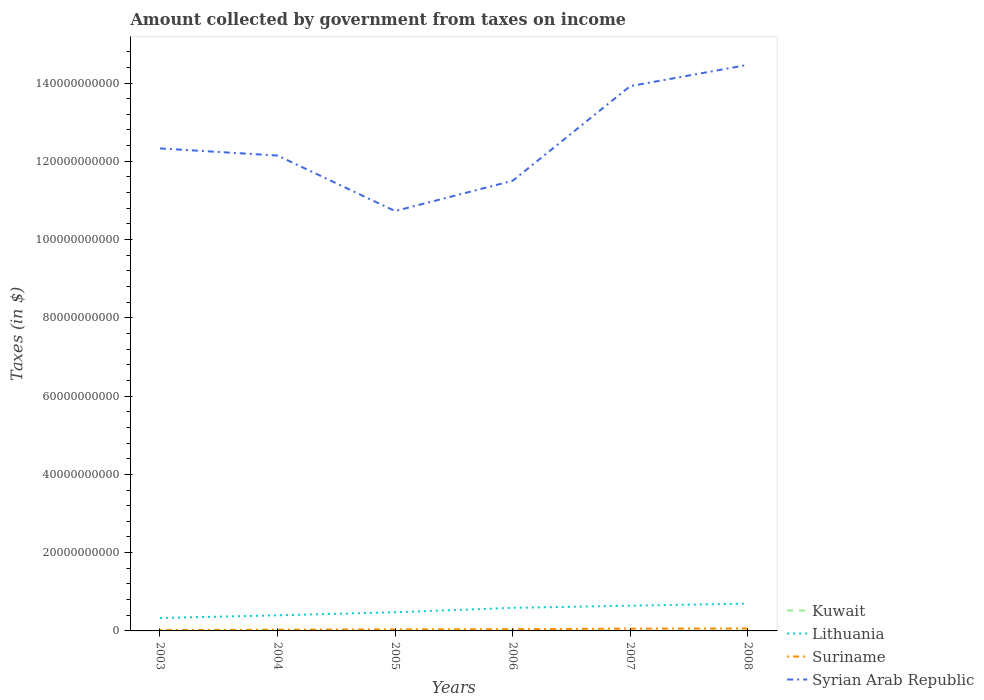Does the line corresponding to Lithuania intersect with the line corresponding to Syrian Arab Republic?
Your answer should be very brief. No. Across all years, what is the maximum amount collected by government from taxes on income in Syrian Arab Republic?
Your answer should be compact. 1.07e+11. In which year was the amount collected by government from taxes on income in Suriname maximum?
Provide a succinct answer. 2003. What is the total amount collected by government from taxes on income in Suriname in the graph?
Keep it short and to the point. -2.92e+08. What is the difference between the highest and the second highest amount collected by government from taxes on income in Lithuania?
Your answer should be compact. 3.69e+09. Is the amount collected by government from taxes on income in Suriname strictly greater than the amount collected by government from taxes on income in Kuwait over the years?
Provide a succinct answer. No. How many lines are there?
Offer a terse response. 4. How many years are there in the graph?
Ensure brevity in your answer.  6. What is the difference between two consecutive major ticks on the Y-axis?
Your answer should be very brief. 2.00e+1. Are the values on the major ticks of Y-axis written in scientific E-notation?
Your answer should be compact. No. Does the graph contain any zero values?
Offer a terse response. No. Where does the legend appear in the graph?
Your answer should be compact. Bottom right. What is the title of the graph?
Provide a short and direct response. Amount collected by government from taxes on income. What is the label or title of the X-axis?
Your answer should be very brief. Years. What is the label or title of the Y-axis?
Offer a terse response. Taxes (in $). What is the Taxes (in $) of Kuwait in 2003?
Keep it short and to the point. 3.00e+07. What is the Taxes (in $) in Lithuania in 2003?
Offer a terse response. 3.29e+09. What is the Taxes (in $) of Suriname in 2003?
Provide a short and direct response. 2.10e+08. What is the Taxes (in $) of Syrian Arab Republic in 2003?
Ensure brevity in your answer.  1.23e+11. What is the Taxes (in $) in Kuwait in 2004?
Your answer should be very brief. 5.30e+07. What is the Taxes (in $) in Lithuania in 2004?
Your answer should be compact. 3.99e+09. What is the Taxes (in $) of Suriname in 2004?
Give a very brief answer. 3.03e+08. What is the Taxes (in $) in Syrian Arab Republic in 2004?
Your answer should be compact. 1.21e+11. What is the Taxes (in $) in Kuwait in 2005?
Provide a short and direct response. 5.80e+07. What is the Taxes (in $) in Lithuania in 2005?
Offer a very short reply. 4.77e+09. What is the Taxes (in $) in Suriname in 2005?
Your answer should be very brief. 3.90e+08. What is the Taxes (in $) in Syrian Arab Republic in 2005?
Your answer should be very brief. 1.07e+11. What is the Taxes (in $) of Kuwait in 2006?
Make the answer very short. 8.20e+07. What is the Taxes (in $) in Lithuania in 2006?
Provide a succinct answer. 5.89e+09. What is the Taxes (in $) in Suriname in 2006?
Offer a terse response. 4.40e+08. What is the Taxes (in $) in Syrian Arab Republic in 2006?
Keep it short and to the point. 1.15e+11. What is the Taxes (in $) of Kuwait in 2007?
Offer a terse response. 1.09e+08. What is the Taxes (in $) of Lithuania in 2007?
Your answer should be very brief. 6.44e+09. What is the Taxes (in $) of Suriname in 2007?
Your response must be concise. 5.95e+08. What is the Taxes (in $) of Syrian Arab Republic in 2007?
Keep it short and to the point. 1.39e+11. What is the Taxes (in $) of Kuwait in 2008?
Your answer should be compact. 1.22e+08. What is the Taxes (in $) in Lithuania in 2008?
Offer a terse response. 6.99e+09. What is the Taxes (in $) in Suriname in 2008?
Make the answer very short. 6.34e+08. What is the Taxes (in $) in Syrian Arab Republic in 2008?
Your response must be concise. 1.45e+11. Across all years, what is the maximum Taxes (in $) in Kuwait?
Ensure brevity in your answer.  1.22e+08. Across all years, what is the maximum Taxes (in $) of Lithuania?
Offer a terse response. 6.99e+09. Across all years, what is the maximum Taxes (in $) in Suriname?
Give a very brief answer. 6.34e+08. Across all years, what is the maximum Taxes (in $) of Syrian Arab Republic?
Give a very brief answer. 1.45e+11. Across all years, what is the minimum Taxes (in $) in Kuwait?
Provide a short and direct response. 3.00e+07. Across all years, what is the minimum Taxes (in $) in Lithuania?
Give a very brief answer. 3.29e+09. Across all years, what is the minimum Taxes (in $) in Suriname?
Your answer should be compact. 2.10e+08. Across all years, what is the minimum Taxes (in $) in Syrian Arab Republic?
Ensure brevity in your answer.  1.07e+11. What is the total Taxes (in $) in Kuwait in the graph?
Offer a very short reply. 4.54e+08. What is the total Taxes (in $) in Lithuania in the graph?
Make the answer very short. 3.14e+1. What is the total Taxes (in $) of Suriname in the graph?
Offer a terse response. 2.57e+09. What is the total Taxes (in $) in Syrian Arab Republic in the graph?
Keep it short and to the point. 7.51e+11. What is the difference between the Taxes (in $) in Kuwait in 2003 and that in 2004?
Your answer should be very brief. -2.30e+07. What is the difference between the Taxes (in $) of Lithuania in 2003 and that in 2004?
Provide a succinct answer. -6.95e+08. What is the difference between the Taxes (in $) in Suriname in 2003 and that in 2004?
Make the answer very short. -9.29e+07. What is the difference between the Taxes (in $) of Syrian Arab Republic in 2003 and that in 2004?
Keep it short and to the point. 1.83e+09. What is the difference between the Taxes (in $) in Kuwait in 2003 and that in 2005?
Provide a short and direct response. -2.80e+07. What is the difference between the Taxes (in $) in Lithuania in 2003 and that in 2005?
Your response must be concise. -1.47e+09. What is the difference between the Taxes (in $) in Suriname in 2003 and that in 2005?
Your answer should be very brief. -1.80e+08. What is the difference between the Taxes (in $) of Syrian Arab Republic in 2003 and that in 2005?
Give a very brief answer. 1.60e+1. What is the difference between the Taxes (in $) of Kuwait in 2003 and that in 2006?
Ensure brevity in your answer.  -5.20e+07. What is the difference between the Taxes (in $) in Lithuania in 2003 and that in 2006?
Your response must be concise. -2.60e+09. What is the difference between the Taxes (in $) in Suriname in 2003 and that in 2006?
Give a very brief answer. -2.30e+08. What is the difference between the Taxes (in $) of Syrian Arab Republic in 2003 and that in 2006?
Provide a succinct answer. 8.27e+09. What is the difference between the Taxes (in $) of Kuwait in 2003 and that in 2007?
Ensure brevity in your answer.  -7.90e+07. What is the difference between the Taxes (in $) of Lithuania in 2003 and that in 2007?
Your answer should be very brief. -3.15e+09. What is the difference between the Taxes (in $) of Suriname in 2003 and that in 2007?
Make the answer very short. -3.85e+08. What is the difference between the Taxes (in $) in Syrian Arab Republic in 2003 and that in 2007?
Your answer should be very brief. -1.59e+1. What is the difference between the Taxes (in $) of Kuwait in 2003 and that in 2008?
Ensure brevity in your answer.  -9.20e+07. What is the difference between the Taxes (in $) in Lithuania in 2003 and that in 2008?
Provide a short and direct response. -3.69e+09. What is the difference between the Taxes (in $) of Suriname in 2003 and that in 2008?
Offer a terse response. -4.24e+08. What is the difference between the Taxes (in $) in Syrian Arab Republic in 2003 and that in 2008?
Give a very brief answer. -2.13e+1. What is the difference between the Taxes (in $) in Kuwait in 2004 and that in 2005?
Offer a very short reply. -5.00e+06. What is the difference between the Taxes (in $) of Lithuania in 2004 and that in 2005?
Ensure brevity in your answer.  -7.78e+08. What is the difference between the Taxes (in $) in Suriname in 2004 and that in 2005?
Make the answer very short. -8.72e+07. What is the difference between the Taxes (in $) of Syrian Arab Republic in 2004 and that in 2005?
Ensure brevity in your answer.  1.42e+1. What is the difference between the Taxes (in $) in Kuwait in 2004 and that in 2006?
Offer a very short reply. -2.90e+07. What is the difference between the Taxes (in $) in Lithuania in 2004 and that in 2006?
Your response must be concise. -1.90e+09. What is the difference between the Taxes (in $) of Suriname in 2004 and that in 2006?
Keep it short and to the point. -1.37e+08. What is the difference between the Taxes (in $) of Syrian Arab Republic in 2004 and that in 2006?
Ensure brevity in your answer.  6.45e+09. What is the difference between the Taxes (in $) of Kuwait in 2004 and that in 2007?
Your answer should be very brief. -5.60e+07. What is the difference between the Taxes (in $) in Lithuania in 2004 and that in 2007?
Offer a terse response. -2.46e+09. What is the difference between the Taxes (in $) in Suriname in 2004 and that in 2007?
Offer a terse response. -2.92e+08. What is the difference between the Taxes (in $) of Syrian Arab Republic in 2004 and that in 2007?
Provide a short and direct response. -1.77e+1. What is the difference between the Taxes (in $) of Kuwait in 2004 and that in 2008?
Your response must be concise. -6.90e+07. What is the difference between the Taxes (in $) of Lithuania in 2004 and that in 2008?
Ensure brevity in your answer.  -3.00e+09. What is the difference between the Taxes (in $) in Suriname in 2004 and that in 2008?
Give a very brief answer. -3.31e+08. What is the difference between the Taxes (in $) of Syrian Arab Republic in 2004 and that in 2008?
Give a very brief answer. -2.32e+1. What is the difference between the Taxes (in $) in Kuwait in 2005 and that in 2006?
Ensure brevity in your answer.  -2.40e+07. What is the difference between the Taxes (in $) in Lithuania in 2005 and that in 2006?
Make the answer very short. -1.13e+09. What is the difference between the Taxes (in $) of Suriname in 2005 and that in 2006?
Your answer should be compact. -4.96e+07. What is the difference between the Taxes (in $) in Syrian Arab Republic in 2005 and that in 2006?
Provide a succinct answer. -7.73e+09. What is the difference between the Taxes (in $) of Kuwait in 2005 and that in 2007?
Offer a terse response. -5.10e+07. What is the difference between the Taxes (in $) of Lithuania in 2005 and that in 2007?
Offer a very short reply. -1.68e+09. What is the difference between the Taxes (in $) in Suriname in 2005 and that in 2007?
Provide a short and direct response. -2.05e+08. What is the difference between the Taxes (in $) in Syrian Arab Republic in 2005 and that in 2007?
Provide a succinct answer. -3.19e+1. What is the difference between the Taxes (in $) in Kuwait in 2005 and that in 2008?
Ensure brevity in your answer.  -6.40e+07. What is the difference between the Taxes (in $) in Lithuania in 2005 and that in 2008?
Give a very brief answer. -2.22e+09. What is the difference between the Taxes (in $) of Suriname in 2005 and that in 2008?
Give a very brief answer. -2.44e+08. What is the difference between the Taxes (in $) of Syrian Arab Republic in 2005 and that in 2008?
Provide a short and direct response. -3.73e+1. What is the difference between the Taxes (in $) of Kuwait in 2006 and that in 2007?
Your answer should be very brief. -2.70e+07. What is the difference between the Taxes (in $) of Lithuania in 2006 and that in 2007?
Your response must be concise. -5.51e+08. What is the difference between the Taxes (in $) of Suriname in 2006 and that in 2007?
Keep it short and to the point. -1.55e+08. What is the difference between the Taxes (in $) in Syrian Arab Republic in 2006 and that in 2007?
Offer a terse response. -2.42e+1. What is the difference between the Taxes (in $) in Kuwait in 2006 and that in 2008?
Your answer should be very brief. -4.00e+07. What is the difference between the Taxes (in $) in Lithuania in 2006 and that in 2008?
Provide a succinct answer. -1.09e+09. What is the difference between the Taxes (in $) of Suriname in 2006 and that in 2008?
Your answer should be compact. -1.94e+08. What is the difference between the Taxes (in $) of Syrian Arab Republic in 2006 and that in 2008?
Your answer should be compact. -2.96e+1. What is the difference between the Taxes (in $) of Kuwait in 2007 and that in 2008?
Offer a terse response. -1.30e+07. What is the difference between the Taxes (in $) in Lithuania in 2007 and that in 2008?
Provide a short and direct response. -5.42e+08. What is the difference between the Taxes (in $) of Suriname in 2007 and that in 2008?
Make the answer very short. -3.89e+07. What is the difference between the Taxes (in $) of Syrian Arab Republic in 2007 and that in 2008?
Provide a short and direct response. -5.43e+09. What is the difference between the Taxes (in $) of Kuwait in 2003 and the Taxes (in $) of Lithuania in 2004?
Your response must be concise. -3.96e+09. What is the difference between the Taxes (in $) in Kuwait in 2003 and the Taxes (in $) in Suriname in 2004?
Your response must be concise. -2.73e+08. What is the difference between the Taxes (in $) of Kuwait in 2003 and the Taxes (in $) of Syrian Arab Republic in 2004?
Make the answer very short. -1.21e+11. What is the difference between the Taxes (in $) in Lithuania in 2003 and the Taxes (in $) in Suriname in 2004?
Give a very brief answer. 2.99e+09. What is the difference between the Taxes (in $) of Lithuania in 2003 and the Taxes (in $) of Syrian Arab Republic in 2004?
Make the answer very short. -1.18e+11. What is the difference between the Taxes (in $) of Suriname in 2003 and the Taxes (in $) of Syrian Arab Republic in 2004?
Ensure brevity in your answer.  -1.21e+11. What is the difference between the Taxes (in $) of Kuwait in 2003 and the Taxes (in $) of Lithuania in 2005?
Offer a terse response. -4.74e+09. What is the difference between the Taxes (in $) of Kuwait in 2003 and the Taxes (in $) of Suriname in 2005?
Provide a succinct answer. -3.60e+08. What is the difference between the Taxes (in $) in Kuwait in 2003 and the Taxes (in $) in Syrian Arab Republic in 2005?
Give a very brief answer. -1.07e+11. What is the difference between the Taxes (in $) in Lithuania in 2003 and the Taxes (in $) in Suriname in 2005?
Provide a short and direct response. 2.90e+09. What is the difference between the Taxes (in $) of Lithuania in 2003 and the Taxes (in $) of Syrian Arab Republic in 2005?
Provide a succinct answer. -1.04e+11. What is the difference between the Taxes (in $) of Suriname in 2003 and the Taxes (in $) of Syrian Arab Republic in 2005?
Keep it short and to the point. -1.07e+11. What is the difference between the Taxes (in $) of Kuwait in 2003 and the Taxes (in $) of Lithuania in 2006?
Your response must be concise. -5.86e+09. What is the difference between the Taxes (in $) of Kuwait in 2003 and the Taxes (in $) of Suriname in 2006?
Offer a very short reply. -4.10e+08. What is the difference between the Taxes (in $) in Kuwait in 2003 and the Taxes (in $) in Syrian Arab Republic in 2006?
Offer a very short reply. -1.15e+11. What is the difference between the Taxes (in $) of Lithuania in 2003 and the Taxes (in $) of Suriname in 2006?
Ensure brevity in your answer.  2.86e+09. What is the difference between the Taxes (in $) in Lithuania in 2003 and the Taxes (in $) in Syrian Arab Republic in 2006?
Your response must be concise. -1.12e+11. What is the difference between the Taxes (in $) in Suriname in 2003 and the Taxes (in $) in Syrian Arab Republic in 2006?
Keep it short and to the point. -1.15e+11. What is the difference between the Taxes (in $) in Kuwait in 2003 and the Taxes (in $) in Lithuania in 2007?
Offer a terse response. -6.42e+09. What is the difference between the Taxes (in $) of Kuwait in 2003 and the Taxes (in $) of Suriname in 2007?
Give a very brief answer. -5.65e+08. What is the difference between the Taxes (in $) of Kuwait in 2003 and the Taxes (in $) of Syrian Arab Republic in 2007?
Your answer should be very brief. -1.39e+11. What is the difference between the Taxes (in $) in Lithuania in 2003 and the Taxes (in $) in Suriname in 2007?
Offer a very short reply. 2.70e+09. What is the difference between the Taxes (in $) in Lithuania in 2003 and the Taxes (in $) in Syrian Arab Republic in 2007?
Give a very brief answer. -1.36e+11. What is the difference between the Taxes (in $) of Suriname in 2003 and the Taxes (in $) of Syrian Arab Republic in 2007?
Provide a short and direct response. -1.39e+11. What is the difference between the Taxes (in $) in Kuwait in 2003 and the Taxes (in $) in Lithuania in 2008?
Your answer should be very brief. -6.96e+09. What is the difference between the Taxes (in $) in Kuwait in 2003 and the Taxes (in $) in Suriname in 2008?
Your response must be concise. -6.04e+08. What is the difference between the Taxes (in $) in Kuwait in 2003 and the Taxes (in $) in Syrian Arab Republic in 2008?
Give a very brief answer. -1.45e+11. What is the difference between the Taxes (in $) of Lithuania in 2003 and the Taxes (in $) of Suriname in 2008?
Keep it short and to the point. 2.66e+09. What is the difference between the Taxes (in $) in Lithuania in 2003 and the Taxes (in $) in Syrian Arab Republic in 2008?
Your response must be concise. -1.41e+11. What is the difference between the Taxes (in $) in Suriname in 2003 and the Taxes (in $) in Syrian Arab Republic in 2008?
Offer a very short reply. -1.44e+11. What is the difference between the Taxes (in $) in Kuwait in 2004 and the Taxes (in $) in Lithuania in 2005?
Your answer should be compact. -4.71e+09. What is the difference between the Taxes (in $) of Kuwait in 2004 and the Taxes (in $) of Suriname in 2005?
Your answer should be compact. -3.37e+08. What is the difference between the Taxes (in $) in Kuwait in 2004 and the Taxes (in $) in Syrian Arab Republic in 2005?
Offer a terse response. -1.07e+11. What is the difference between the Taxes (in $) in Lithuania in 2004 and the Taxes (in $) in Suriname in 2005?
Provide a short and direct response. 3.60e+09. What is the difference between the Taxes (in $) in Lithuania in 2004 and the Taxes (in $) in Syrian Arab Republic in 2005?
Keep it short and to the point. -1.03e+11. What is the difference between the Taxes (in $) of Suriname in 2004 and the Taxes (in $) of Syrian Arab Republic in 2005?
Provide a succinct answer. -1.07e+11. What is the difference between the Taxes (in $) in Kuwait in 2004 and the Taxes (in $) in Lithuania in 2006?
Keep it short and to the point. -5.84e+09. What is the difference between the Taxes (in $) of Kuwait in 2004 and the Taxes (in $) of Suriname in 2006?
Provide a short and direct response. -3.87e+08. What is the difference between the Taxes (in $) in Kuwait in 2004 and the Taxes (in $) in Syrian Arab Republic in 2006?
Keep it short and to the point. -1.15e+11. What is the difference between the Taxes (in $) of Lithuania in 2004 and the Taxes (in $) of Suriname in 2006?
Keep it short and to the point. 3.55e+09. What is the difference between the Taxes (in $) in Lithuania in 2004 and the Taxes (in $) in Syrian Arab Republic in 2006?
Your answer should be very brief. -1.11e+11. What is the difference between the Taxes (in $) of Suriname in 2004 and the Taxes (in $) of Syrian Arab Republic in 2006?
Your answer should be very brief. -1.15e+11. What is the difference between the Taxes (in $) in Kuwait in 2004 and the Taxes (in $) in Lithuania in 2007?
Your answer should be very brief. -6.39e+09. What is the difference between the Taxes (in $) of Kuwait in 2004 and the Taxes (in $) of Suriname in 2007?
Offer a terse response. -5.42e+08. What is the difference between the Taxes (in $) in Kuwait in 2004 and the Taxes (in $) in Syrian Arab Republic in 2007?
Give a very brief answer. -1.39e+11. What is the difference between the Taxes (in $) in Lithuania in 2004 and the Taxes (in $) in Suriname in 2007?
Provide a succinct answer. 3.39e+09. What is the difference between the Taxes (in $) in Lithuania in 2004 and the Taxes (in $) in Syrian Arab Republic in 2007?
Your answer should be compact. -1.35e+11. What is the difference between the Taxes (in $) in Suriname in 2004 and the Taxes (in $) in Syrian Arab Republic in 2007?
Provide a succinct answer. -1.39e+11. What is the difference between the Taxes (in $) of Kuwait in 2004 and the Taxes (in $) of Lithuania in 2008?
Keep it short and to the point. -6.93e+09. What is the difference between the Taxes (in $) in Kuwait in 2004 and the Taxes (in $) in Suriname in 2008?
Keep it short and to the point. -5.81e+08. What is the difference between the Taxes (in $) in Kuwait in 2004 and the Taxes (in $) in Syrian Arab Republic in 2008?
Make the answer very short. -1.45e+11. What is the difference between the Taxes (in $) in Lithuania in 2004 and the Taxes (in $) in Suriname in 2008?
Keep it short and to the point. 3.36e+09. What is the difference between the Taxes (in $) of Lithuania in 2004 and the Taxes (in $) of Syrian Arab Republic in 2008?
Offer a terse response. -1.41e+11. What is the difference between the Taxes (in $) of Suriname in 2004 and the Taxes (in $) of Syrian Arab Republic in 2008?
Offer a very short reply. -1.44e+11. What is the difference between the Taxes (in $) in Kuwait in 2005 and the Taxes (in $) in Lithuania in 2006?
Offer a very short reply. -5.84e+09. What is the difference between the Taxes (in $) in Kuwait in 2005 and the Taxes (in $) in Suriname in 2006?
Offer a very short reply. -3.82e+08. What is the difference between the Taxes (in $) in Kuwait in 2005 and the Taxes (in $) in Syrian Arab Republic in 2006?
Keep it short and to the point. -1.15e+11. What is the difference between the Taxes (in $) of Lithuania in 2005 and the Taxes (in $) of Suriname in 2006?
Your response must be concise. 4.33e+09. What is the difference between the Taxes (in $) of Lithuania in 2005 and the Taxes (in $) of Syrian Arab Republic in 2006?
Offer a terse response. -1.10e+11. What is the difference between the Taxes (in $) of Suriname in 2005 and the Taxes (in $) of Syrian Arab Republic in 2006?
Offer a very short reply. -1.15e+11. What is the difference between the Taxes (in $) of Kuwait in 2005 and the Taxes (in $) of Lithuania in 2007?
Your response must be concise. -6.39e+09. What is the difference between the Taxes (in $) in Kuwait in 2005 and the Taxes (in $) in Suriname in 2007?
Your answer should be compact. -5.37e+08. What is the difference between the Taxes (in $) of Kuwait in 2005 and the Taxes (in $) of Syrian Arab Republic in 2007?
Ensure brevity in your answer.  -1.39e+11. What is the difference between the Taxes (in $) of Lithuania in 2005 and the Taxes (in $) of Suriname in 2007?
Your answer should be compact. 4.17e+09. What is the difference between the Taxes (in $) of Lithuania in 2005 and the Taxes (in $) of Syrian Arab Republic in 2007?
Keep it short and to the point. -1.34e+11. What is the difference between the Taxes (in $) of Suriname in 2005 and the Taxes (in $) of Syrian Arab Republic in 2007?
Give a very brief answer. -1.39e+11. What is the difference between the Taxes (in $) of Kuwait in 2005 and the Taxes (in $) of Lithuania in 2008?
Keep it short and to the point. -6.93e+09. What is the difference between the Taxes (in $) in Kuwait in 2005 and the Taxes (in $) in Suriname in 2008?
Keep it short and to the point. -5.76e+08. What is the difference between the Taxes (in $) of Kuwait in 2005 and the Taxes (in $) of Syrian Arab Republic in 2008?
Ensure brevity in your answer.  -1.45e+11. What is the difference between the Taxes (in $) of Lithuania in 2005 and the Taxes (in $) of Suriname in 2008?
Provide a succinct answer. 4.13e+09. What is the difference between the Taxes (in $) of Lithuania in 2005 and the Taxes (in $) of Syrian Arab Republic in 2008?
Ensure brevity in your answer.  -1.40e+11. What is the difference between the Taxes (in $) of Suriname in 2005 and the Taxes (in $) of Syrian Arab Republic in 2008?
Offer a terse response. -1.44e+11. What is the difference between the Taxes (in $) in Kuwait in 2006 and the Taxes (in $) in Lithuania in 2007?
Your response must be concise. -6.36e+09. What is the difference between the Taxes (in $) of Kuwait in 2006 and the Taxes (in $) of Suriname in 2007?
Provide a succinct answer. -5.13e+08. What is the difference between the Taxes (in $) in Kuwait in 2006 and the Taxes (in $) in Syrian Arab Republic in 2007?
Offer a very short reply. -1.39e+11. What is the difference between the Taxes (in $) of Lithuania in 2006 and the Taxes (in $) of Suriname in 2007?
Offer a terse response. 5.30e+09. What is the difference between the Taxes (in $) in Lithuania in 2006 and the Taxes (in $) in Syrian Arab Republic in 2007?
Offer a terse response. -1.33e+11. What is the difference between the Taxes (in $) of Suriname in 2006 and the Taxes (in $) of Syrian Arab Republic in 2007?
Keep it short and to the point. -1.39e+11. What is the difference between the Taxes (in $) of Kuwait in 2006 and the Taxes (in $) of Lithuania in 2008?
Offer a terse response. -6.90e+09. What is the difference between the Taxes (in $) in Kuwait in 2006 and the Taxes (in $) in Suriname in 2008?
Keep it short and to the point. -5.52e+08. What is the difference between the Taxes (in $) in Kuwait in 2006 and the Taxes (in $) in Syrian Arab Republic in 2008?
Your answer should be very brief. -1.45e+11. What is the difference between the Taxes (in $) in Lithuania in 2006 and the Taxes (in $) in Suriname in 2008?
Offer a terse response. 5.26e+09. What is the difference between the Taxes (in $) of Lithuania in 2006 and the Taxes (in $) of Syrian Arab Republic in 2008?
Ensure brevity in your answer.  -1.39e+11. What is the difference between the Taxes (in $) of Suriname in 2006 and the Taxes (in $) of Syrian Arab Republic in 2008?
Make the answer very short. -1.44e+11. What is the difference between the Taxes (in $) of Kuwait in 2007 and the Taxes (in $) of Lithuania in 2008?
Offer a very short reply. -6.88e+09. What is the difference between the Taxes (in $) in Kuwait in 2007 and the Taxes (in $) in Suriname in 2008?
Make the answer very short. -5.25e+08. What is the difference between the Taxes (in $) in Kuwait in 2007 and the Taxes (in $) in Syrian Arab Republic in 2008?
Make the answer very short. -1.45e+11. What is the difference between the Taxes (in $) of Lithuania in 2007 and the Taxes (in $) of Suriname in 2008?
Provide a short and direct response. 5.81e+09. What is the difference between the Taxes (in $) of Lithuania in 2007 and the Taxes (in $) of Syrian Arab Republic in 2008?
Give a very brief answer. -1.38e+11. What is the difference between the Taxes (in $) in Suriname in 2007 and the Taxes (in $) in Syrian Arab Republic in 2008?
Your answer should be very brief. -1.44e+11. What is the average Taxes (in $) of Kuwait per year?
Your response must be concise. 7.57e+07. What is the average Taxes (in $) in Lithuania per year?
Your answer should be compact. 5.23e+09. What is the average Taxes (in $) of Suriname per year?
Ensure brevity in your answer.  4.28e+08. What is the average Taxes (in $) of Syrian Arab Republic per year?
Make the answer very short. 1.25e+11. In the year 2003, what is the difference between the Taxes (in $) of Kuwait and Taxes (in $) of Lithuania?
Your answer should be very brief. -3.26e+09. In the year 2003, what is the difference between the Taxes (in $) of Kuwait and Taxes (in $) of Suriname?
Ensure brevity in your answer.  -1.80e+08. In the year 2003, what is the difference between the Taxes (in $) in Kuwait and Taxes (in $) in Syrian Arab Republic?
Your response must be concise. -1.23e+11. In the year 2003, what is the difference between the Taxes (in $) of Lithuania and Taxes (in $) of Suriname?
Offer a very short reply. 3.09e+09. In the year 2003, what is the difference between the Taxes (in $) of Lithuania and Taxes (in $) of Syrian Arab Republic?
Make the answer very short. -1.20e+11. In the year 2003, what is the difference between the Taxes (in $) in Suriname and Taxes (in $) in Syrian Arab Republic?
Offer a terse response. -1.23e+11. In the year 2004, what is the difference between the Taxes (in $) in Kuwait and Taxes (in $) in Lithuania?
Give a very brief answer. -3.94e+09. In the year 2004, what is the difference between the Taxes (in $) in Kuwait and Taxes (in $) in Suriname?
Provide a short and direct response. -2.50e+08. In the year 2004, what is the difference between the Taxes (in $) of Kuwait and Taxes (in $) of Syrian Arab Republic?
Your answer should be compact. -1.21e+11. In the year 2004, what is the difference between the Taxes (in $) of Lithuania and Taxes (in $) of Suriname?
Provide a succinct answer. 3.69e+09. In the year 2004, what is the difference between the Taxes (in $) in Lithuania and Taxes (in $) in Syrian Arab Republic?
Give a very brief answer. -1.17e+11. In the year 2004, what is the difference between the Taxes (in $) in Suriname and Taxes (in $) in Syrian Arab Republic?
Ensure brevity in your answer.  -1.21e+11. In the year 2005, what is the difference between the Taxes (in $) in Kuwait and Taxes (in $) in Lithuania?
Your response must be concise. -4.71e+09. In the year 2005, what is the difference between the Taxes (in $) of Kuwait and Taxes (in $) of Suriname?
Offer a very short reply. -3.32e+08. In the year 2005, what is the difference between the Taxes (in $) in Kuwait and Taxes (in $) in Syrian Arab Republic?
Make the answer very short. -1.07e+11. In the year 2005, what is the difference between the Taxes (in $) of Lithuania and Taxes (in $) of Suriname?
Ensure brevity in your answer.  4.38e+09. In the year 2005, what is the difference between the Taxes (in $) in Lithuania and Taxes (in $) in Syrian Arab Republic?
Keep it short and to the point. -1.03e+11. In the year 2005, what is the difference between the Taxes (in $) in Suriname and Taxes (in $) in Syrian Arab Republic?
Your answer should be very brief. -1.07e+11. In the year 2006, what is the difference between the Taxes (in $) in Kuwait and Taxes (in $) in Lithuania?
Give a very brief answer. -5.81e+09. In the year 2006, what is the difference between the Taxes (in $) of Kuwait and Taxes (in $) of Suriname?
Provide a short and direct response. -3.58e+08. In the year 2006, what is the difference between the Taxes (in $) of Kuwait and Taxes (in $) of Syrian Arab Republic?
Your answer should be very brief. -1.15e+11. In the year 2006, what is the difference between the Taxes (in $) in Lithuania and Taxes (in $) in Suriname?
Your response must be concise. 5.45e+09. In the year 2006, what is the difference between the Taxes (in $) of Lithuania and Taxes (in $) of Syrian Arab Republic?
Your response must be concise. -1.09e+11. In the year 2006, what is the difference between the Taxes (in $) of Suriname and Taxes (in $) of Syrian Arab Republic?
Provide a short and direct response. -1.15e+11. In the year 2007, what is the difference between the Taxes (in $) in Kuwait and Taxes (in $) in Lithuania?
Your response must be concise. -6.34e+09. In the year 2007, what is the difference between the Taxes (in $) of Kuwait and Taxes (in $) of Suriname?
Provide a succinct answer. -4.86e+08. In the year 2007, what is the difference between the Taxes (in $) in Kuwait and Taxes (in $) in Syrian Arab Republic?
Ensure brevity in your answer.  -1.39e+11. In the year 2007, what is the difference between the Taxes (in $) of Lithuania and Taxes (in $) of Suriname?
Give a very brief answer. 5.85e+09. In the year 2007, what is the difference between the Taxes (in $) of Lithuania and Taxes (in $) of Syrian Arab Republic?
Make the answer very short. -1.33e+11. In the year 2007, what is the difference between the Taxes (in $) of Suriname and Taxes (in $) of Syrian Arab Republic?
Offer a very short reply. -1.39e+11. In the year 2008, what is the difference between the Taxes (in $) in Kuwait and Taxes (in $) in Lithuania?
Provide a succinct answer. -6.86e+09. In the year 2008, what is the difference between the Taxes (in $) of Kuwait and Taxes (in $) of Suriname?
Ensure brevity in your answer.  -5.12e+08. In the year 2008, what is the difference between the Taxes (in $) in Kuwait and Taxes (in $) in Syrian Arab Republic?
Keep it short and to the point. -1.45e+11. In the year 2008, what is the difference between the Taxes (in $) of Lithuania and Taxes (in $) of Suriname?
Give a very brief answer. 6.35e+09. In the year 2008, what is the difference between the Taxes (in $) in Lithuania and Taxes (in $) in Syrian Arab Republic?
Your answer should be very brief. -1.38e+11. In the year 2008, what is the difference between the Taxes (in $) in Suriname and Taxes (in $) in Syrian Arab Republic?
Provide a short and direct response. -1.44e+11. What is the ratio of the Taxes (in $) in Kuwait in 2003 to that in 2004?
Provide a short and direct response. 0.57. What is the ratio of the Taxes (in $) in Lithuania in 2003 to that in 2004?
Provide a succinct answer. 0.83. What is the ratio of the Taxes (in $) of Suriname in 2003 to that in 2004?
Ensure brevity in your answer.  0.69. What is the ratio of the Taxes (in $) in Kuwait in 2003 to that in 2005?
Keep it short and to the point. 0.52. What is the ratio of the Taxes (in $) in Lithuania in 2003 to that in 2005?
Give a very brief answer. 0.69. What is the ratio of the Taxes (in $) in Suriname in 2003 to that in 2005?
Your answer should be very brief. 0.54. What is the ratio of the Taxes (in $) of Syrian Arab Republic in 2003 to that in 2005?
Your answer should be very brief. 1.15. What is the ratio of the Taxes (in $) in Kuwait in 2003 to that in 2006?
Keep it short and to the point. 0.37. What is the ratio of the Taxes (in $) in Lithuania in 2003 to that in 2006?
Provide a short and direct response. 0.56. What is the ratio of the Taxes (in $) of Suriname in 2003 to that in 2006?
Give a very brief answer. 0.48. What is the ratio of the Taxes (in $) of Syrian Arab Republic in 2003 to that in 2006?
Provide a short and direct response. 1.07. What is the ratio of the Taxes (in $) in Kuwait in 2003 to that in 2007?
Offer a very short reply. 0.28. What is the ratio of the Taxes (in $) in Lithuania in 2003 to that in 2007?
Offer a terse response. 0.51. What is the ratio of the Taxes (in $) in Suriname in 2003 to that in 2007?
Provide a succinct answer. 0.35. What is the ratio of the Taxes (in $) in Syrian Arab Republic in 2003 to that in 2007?
Give a very brief answer. 0.89. What is the ratio of the Taxes (in $) in Kuwait in 2003 to that in 2008?
Keep it short and to the point. 0.25. What is the ratio of the Taxes (in $) in Lithuania in 2003 to that in 2008?
Offer a terse response. 0.47. What is the ratio of the Taxes (in $) of Suriname in 2003 to that in 2008?
Make the answer very short. 0.33. What is the ratio of the Taxes (in $) in Syrian Arab Republic in 2003 to that in 2008?
Ensure brevity in your answer.  0.85. What is the ratio of the Taxes (in $) in Kuwait in 2004 to that in 2005?
Offer a very short reply. 0.91. What is the ratio of the Taxes (in $) of Lithuania in 2004 to that in 2005?
Your answer should be very brief. 0.84. What is the ratio of the Taxes (in $) in Suriname in 2004 to that in 2005?
Provide a succinct answer. 0.78. What is the ratio of the Taxes (in $) of Syrian Arab Republic in 2004 to that in 2005?
Give a very brief answer. 1.13. What is the ratio of the Taxes (in $) of Kuwait in 2004 to that in 2006?
Provide a succinct answer. 0.65. What is the ratio of the Taxes (in $) in Lithuania in 2004 to that in 2006?
Provide a succinct answer. 0.68. What is the ratio of the Taxes (in $) of Suriname in 2004 to that in 2006?
Keep it short and to the point. 0.69. What is the ratio of the Taxes (in $) of Syrian Arab Republic in 2004 to that in 2006?
Give a very brief answer. 1.06. What is the ratio of the Taxes (in $) in Kuwait in 2004 to that in 2007?
Your response must be concise. 0.49. What is the ratio of the Taxes (in $) of Lithuania in 2004 to that in 2007?
Provide a succinct answer. 0.62. What is the ratio of the Taxes (in $) of Suriname in 2004 to that in 2007?
Provide a succinct answer. 0.51. What is the ratio of the Taxes (in $) in Syrian Arab Republic in 2004 to that in 2007?
Make the answer very short. 0.87. What is the ratio of the Taxes (in $) in Kuwait in 2004 to that in 2008?
Offer a terse response. 0.43. What is the ratio of the Taxes (in $) of Lithuania in 2004 to that in 2008?
Give a very brief answer. 0.57. What is the ratio of the Taxes (in $) in Suriname in 2004 to that in 2008?
Your response must be concise. 0.48. What is the ratio of the Taxes (in $) of Syrian Arab Republic in 2004 to that in 2008?
Your response must be concise. 0.84. What is the ratio of the Taxes (in $) of Kuwait in 2005 to that in 2006?
Provide a succinct answer. 0.71. What is the ratio of the Taxes (in $) of Lithuania in 2005 to that in 2006?
Ensure brevity in your answer.  0.81. What is the ratio of the Taxes (in $) of Suriname in 2005 to that in 2006?
Your response must be concise. 0.89. What is the ratio of the Taxes (in $) in Syrian Arab Republic in 2005 to that in 2006?
Offer a terse response. 0.93. What is the ratio of the Taxes (in $) in Kuwait in 2005 to that in 2007?
Ensure brevity in your answer.  0.53. What is the ratio of the Taxes (in $) of Lithuania in 2005 to that in 2007?
Your response must be concise. 0.74. What is the ratio of the Taxes (in $) of Suriname in 2005 to that in 2007?
Provide a short and direct response. 0.66. What is the ratio of the Taxes (in $) in Syrian Arab Republic in 2005 to that in 2007?
Keep it short and to the point. 0.77. What is the ratio of the Taxes (in $) of Kuwait in 2005 to that in 2008?
Ensure brevity in your answer.  0.48. What is the ratio of the Taxes (in $) in Lithuania in 2005 to that in 2008?
Offer a very short reply. 0.68. What is the ratio of the Taxes (in $) of Suriname in 2005 to that in 2008?
Your response must be concise. 0.62. What is the ratio of the Taxes (in $) in Syrian Arab Republic in 2005 to that in 2008?
Make the answer very short. 0.74. What is the ratio of the Taxes (in $) in Kuwait in 2006 to that in 2007?
Make the answer very short. 0.75. What is the ratio of the Taxes (in $) in Lithuania in 2006 to that in 2007?
Make the answer very short. 0.91. What is the ratio of the Taxes (in $) in Suriname in 2006 to that in 2007?
Your answer should be compact. 0.74. What is the ratio of the Taxes (in $) in Syrian Arab Republic in 2006 to that in 2007?
Your answer should be very brief. 0.83. What is the ratio of the Taxes (in $) in Kuwait in 2006 to that in 2008?
Your answer should be very brief. 0.67. What is the ratio of the Taxes (in $) of Lithuania in 2006 to that in 2008?
Give a very brief answer. 0.84. What is the ratio of the Taxes (in $) of Suriname in 2006 to that in 2008?
Keep it short and to the point. 0.69. What is the ratio of the Taxes (in $) in Syrian Arab Republic in 2006 to that in 2008?
Provide a short and direct response. 0.8. What is the ratio of the Taxes (in $) of Kuwait in 2007 to that in 2008?
Provide a short and direct response. 0.89. What is the ratio of the Taxes (in $) in Lithuania in 2007 to that in 2008?
Your answer should be very brief. 0.92. What is the ratio of the Taxes (in $) in Suriname in 2007 to that in 2008?
Provide a succinct answer. 0.94. What is the ratio of the Taxes (in $) in Syrian Arab Republic in 2007 to that in 2008?
Make the answer very short. 0.96. What is the difference between the highest and the second highest Taxes (in $) of Kuwait?
Make the answer very short. 1.30e+07. What is the difference between the highest and the second highest Taxes (in $) in Lithuania?
Your answer should be very brief. 5.42e+08. What is the difference between the highest and the second highest Taxes (in $) in Suriname?
Your answer should be compact. 3.89e+07. What is the difference between the highest and the second highest Taxes (in $) in Syrian Arab Republic?
Make the answer very short. 5.43e+09. What is the difference between the highest and the lowest Taxes (in $) of Kuwait?
Your response must be concise. 9.20e+07. What is the difference between the highest and the lowest Taxes (in $) in Lithuania?
Provide a short and direct response. 3.69e+09. What is the difference between the highest and the lowest Taxes (in $) of Suriname?
Make the answer very short. 4.24e+08. What is the difference between the highest and the lowest Taxes (in $) in Syrian Arab Republic?
Offer a terse response. 3.73e+1. 